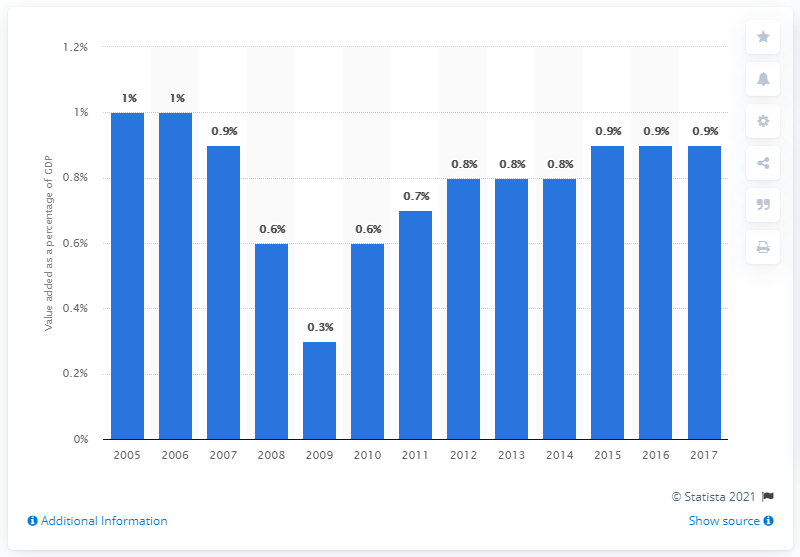Specify some key components in this picture. In 2017, motor vehicle and parts manufacturing accounted for 0.9% of the nation's Gross Domestic Product, contributing significantly to the country's economic output. 